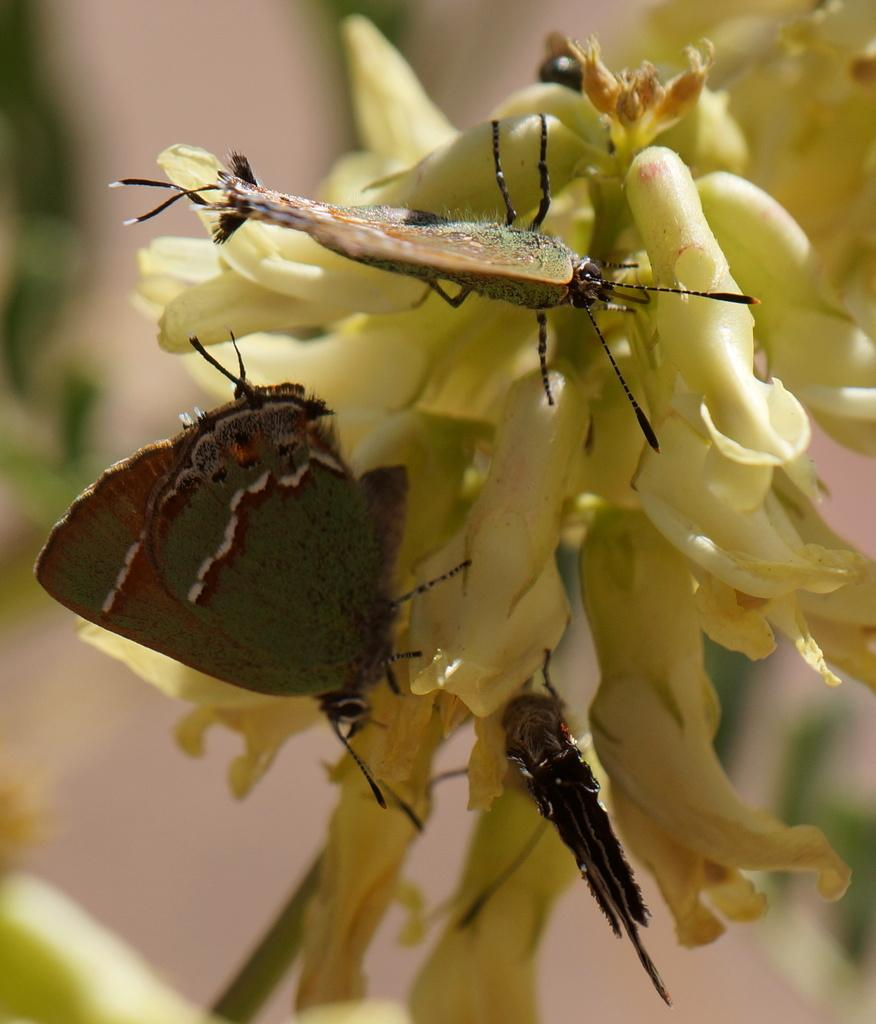What type of creatures can be seen in the image? There are butterflies in the image. Where are the butterflies located in the image? The butterflies are on flowers. What is the name of the butterfly on the back of the rice in the image? There is no rice present in the image, and therefore no butterfly on the back of the rice. 